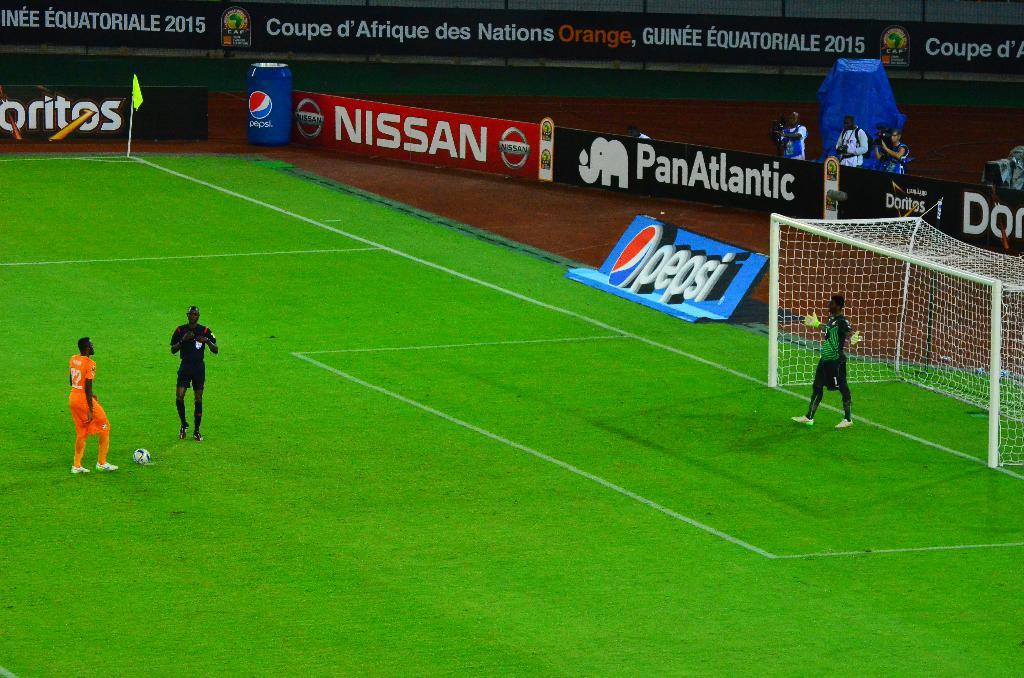What brand is advertised in red?
Your answer should be compact. Nissan. What brand of soda is seen here?
Your answer should be compact. Pepsi. 